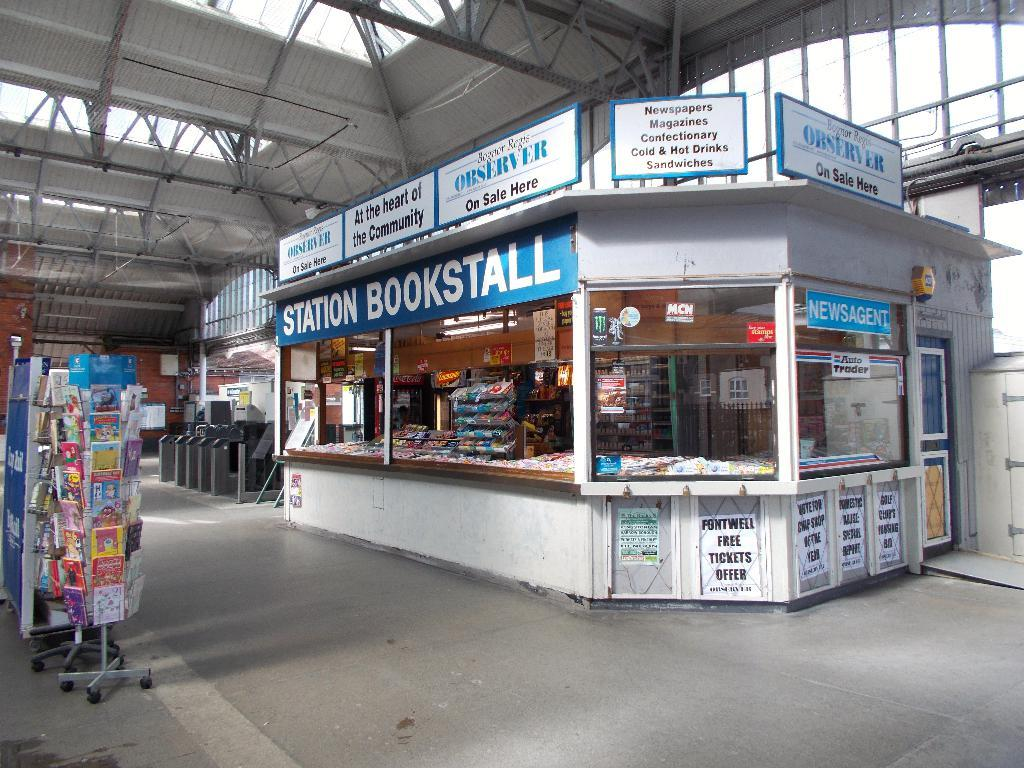<image>
Provide a brief description of the given image. Bookstall in white and blue inside a station 